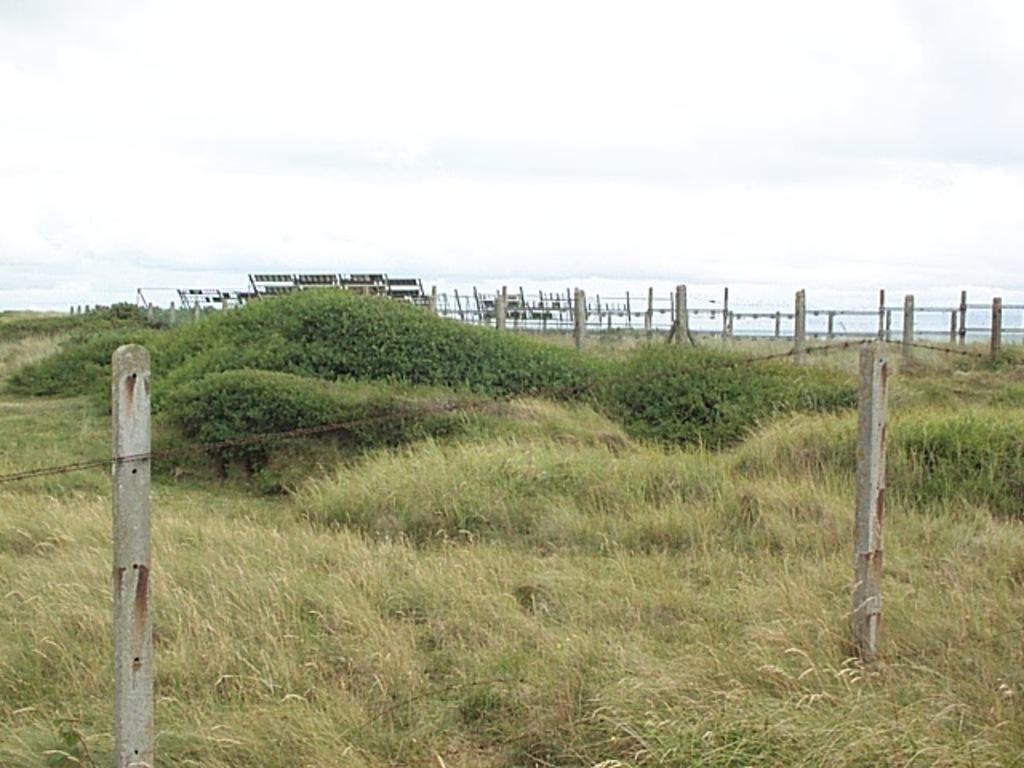In one or two sentences, can you explain what this image depicts? In this image there is a grass in the middle which is covered by the fencing. At the top there is sky. In the middle there are plants beside the grass. 